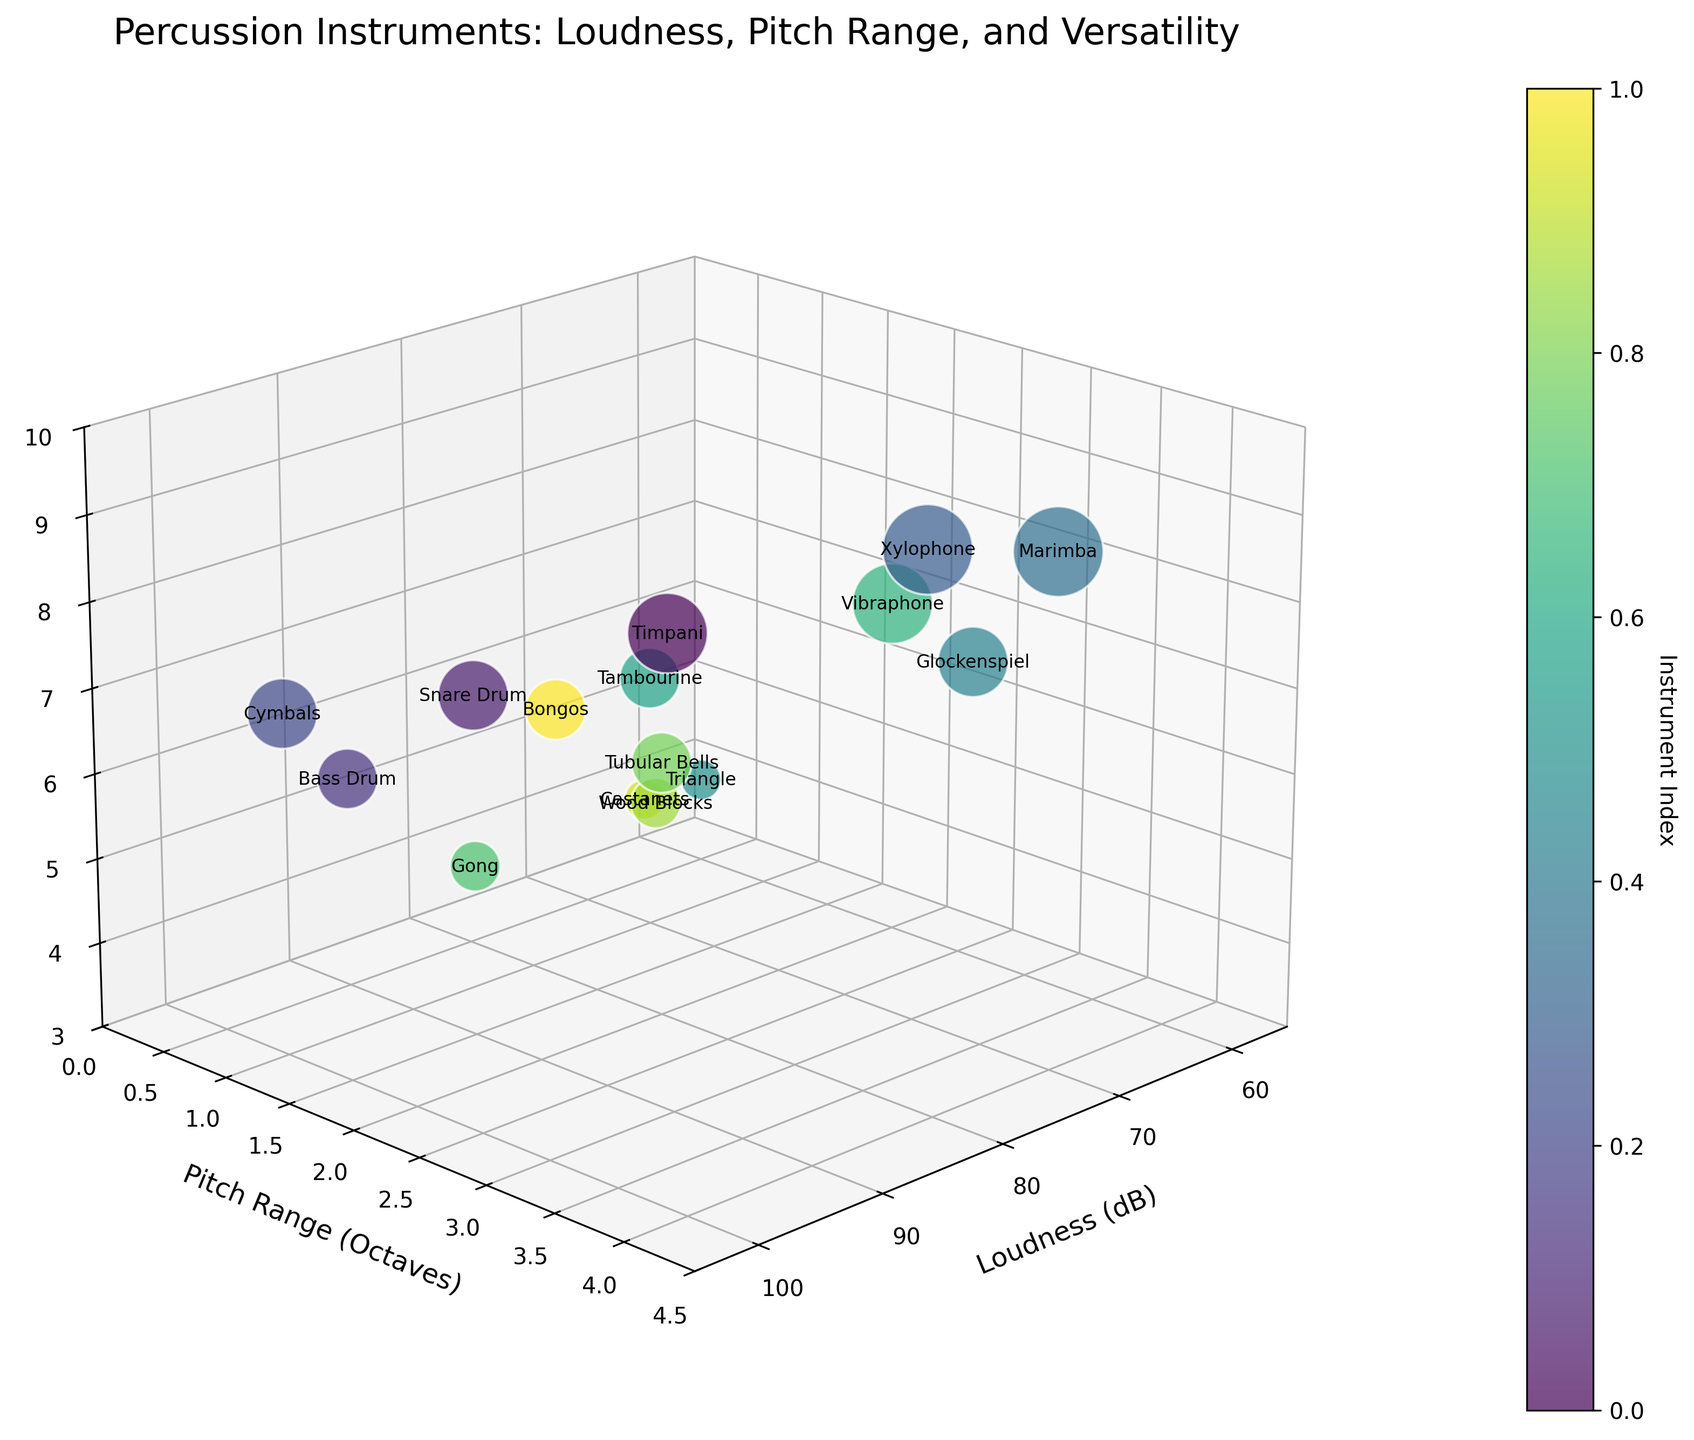How many instruments are displayed in the plot? Count the number of data points or labels shown in the plot. Each instrument corresponds to a data point or label.
Answer: 15 What is the title of the plot? Look at the top of the plot where the title is usually placed.
Answer: Percussion Instruments: Loudness, Pitch Range, and Versatility Which instrument has the highest loudness? Identify the data point with the highest value on the Loudness (dB) axis.
Answer: Cymbals Which instrument has the lowest versatility? Find the data point with the lowest value on the Versatility (1-10) axis.
Answer: Triangle and Castanets (both have a value of 4) What is the average pitch range of all the instruments? Add the pitch ranges of all instruments and divide by the number of instruments: (2.5+1.5+1+1+3.5+4+3+0.5+1+3+1.5+2+1.5+0.5+1)/15 = 26.5/15
Answer: 1.77 Which instruments share the same versatility rating of 7? Identify the data points with a versatility value of 7 and note their corresponding instruments: Snare Drum, Cymbals, Glockenspiel
Answer: Snare Drum, Cymbals, Glockenspiel Which two instruments have the same loudness but different versatility? Check the instruments with identical loudness values but differing versatility values. For Loudness (dB) values of 70: Tambourine (Versatility 6) and Marimba (Versatility 9)
Answer: Tambourine and Marimba Which instrument has the broadest pitch range? Look for the instrument with the highest value on the Pitch Range (Octaves) axis.
Answer: Marimba Are there any instruments with a loudness below 65 dB? Find data points with a Loudness (dB) value less than 65 dB.
Answer: No How do the Timpani and Vibraphone compare in terms of loudness, pitch range, and versatility? Compare the values of these two instruments directly in the three categories:
    - Loudness: Timpani (85 dB) vs. Vibraphone (72 dB)
    - Pitch Range: Timpani (2.5 octaves) vs. Vibraphone (3 octaves)
    - Versatility: Timpani (8) vs. Vibraphone (8)
Answer: Timpani is louder, Vibraphone has a wider pitch range, and both have the same versatility 